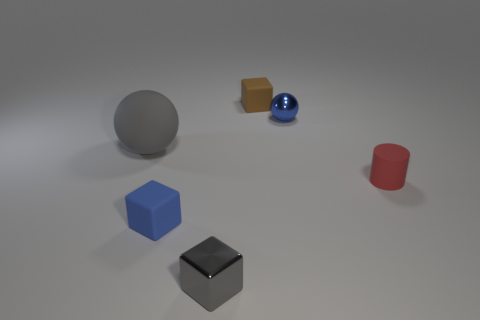What color is the cylinder that is the same material as the big ball?
Ensure brevity in your answer.  Red. What number of tiny cylinders are made of the same material as the large gray sphere?
Offer a terse response. 1. Does the metal thing that is behind the rubber ball have the same size as the rubber block that is in front of the brown block?
Your response must be concise. Yes. What is the ball to the right of the tiny matte thing that is on the left side of the small gray cube made of?
Offer a very short reply. Metal. Is the number of brown rubber objects right of the blue shiny object less than the number of gray things that are in front of the red cylinder?
Give a very brief answer. Yes. There is a big ball that is the same color as the shiny cube; what is it made of?
Make the answer very short. Rubber. Is there any other thing that is the same shape as the red rubber object?
Your answer should be very brief. No. There is a gray object in front of the matte cylinder; what is it made of?
Keep it short and to the point. Metal. Is there any other thing that is the same size as the gray rubber thing?
Make the answer very short. No. Are there any rubber cubes in front of the big gray matte ball?
Your response must be concise. Yes. 